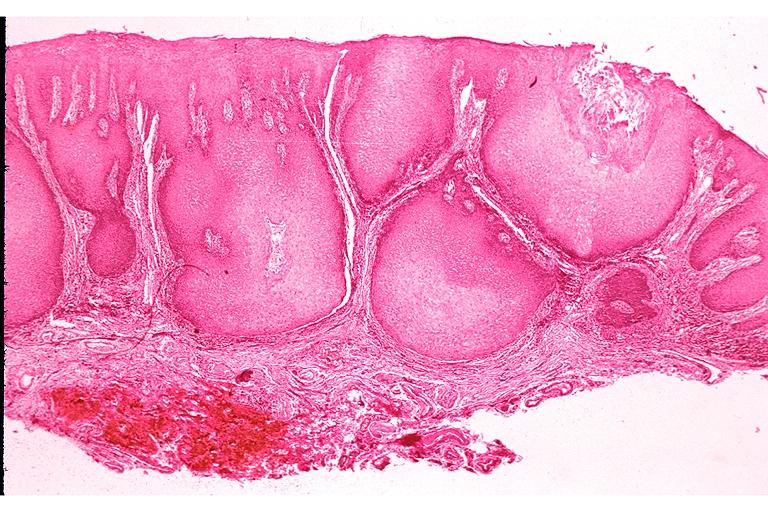s oral present?
Answer the question using a single word or phrase. Yes 